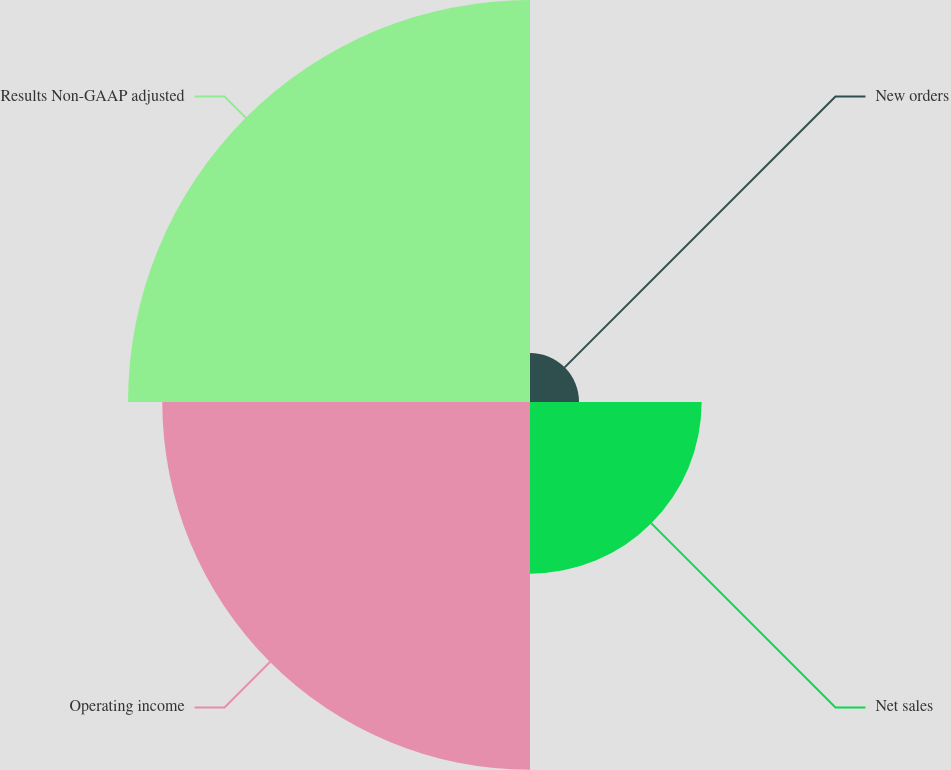Convert chart. <chart><loc_0><loc_0><loc_500><loc_500><pie_chart><fcel>New orders<fcel>Net sales<fcel>Operating income<fcel>Results Non-GAAP adjusted<nl><fcel>4.95%<fcel>17.33%<fcel>37.13%<fcel>40.59%<nl></chart> 